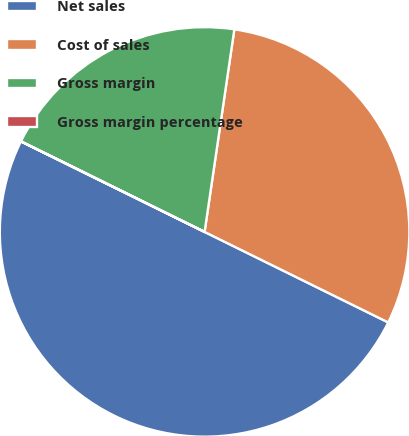Convert chart to OTSL. <chart><loc_0><loc_0><loc_500><loc_500><pie_chart><fcel>Net sales<fcel>Cost of sales<fcel>Gross margin<fcel>Gross margin percentage<nl><fcel>50.0%<fcel>29.97%<fcel>20.03%<fcel>0.01%<nl></chart> 